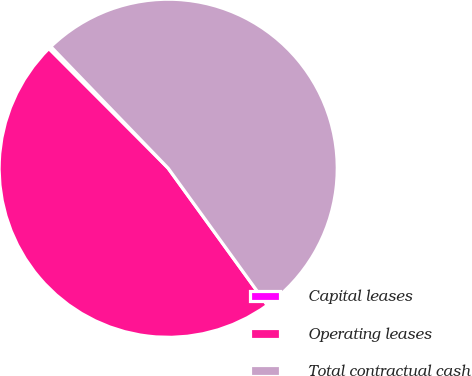Convert chart. <chart><loc_0><loc_0><loc_500><loc_500><pie_chart><fcel>Capital leases<fcel>Operating leases<fcel>Total contractual cash<nl><fcel>0.27%<fcel>47.49%<fcel>52.24%<nl></chart> 